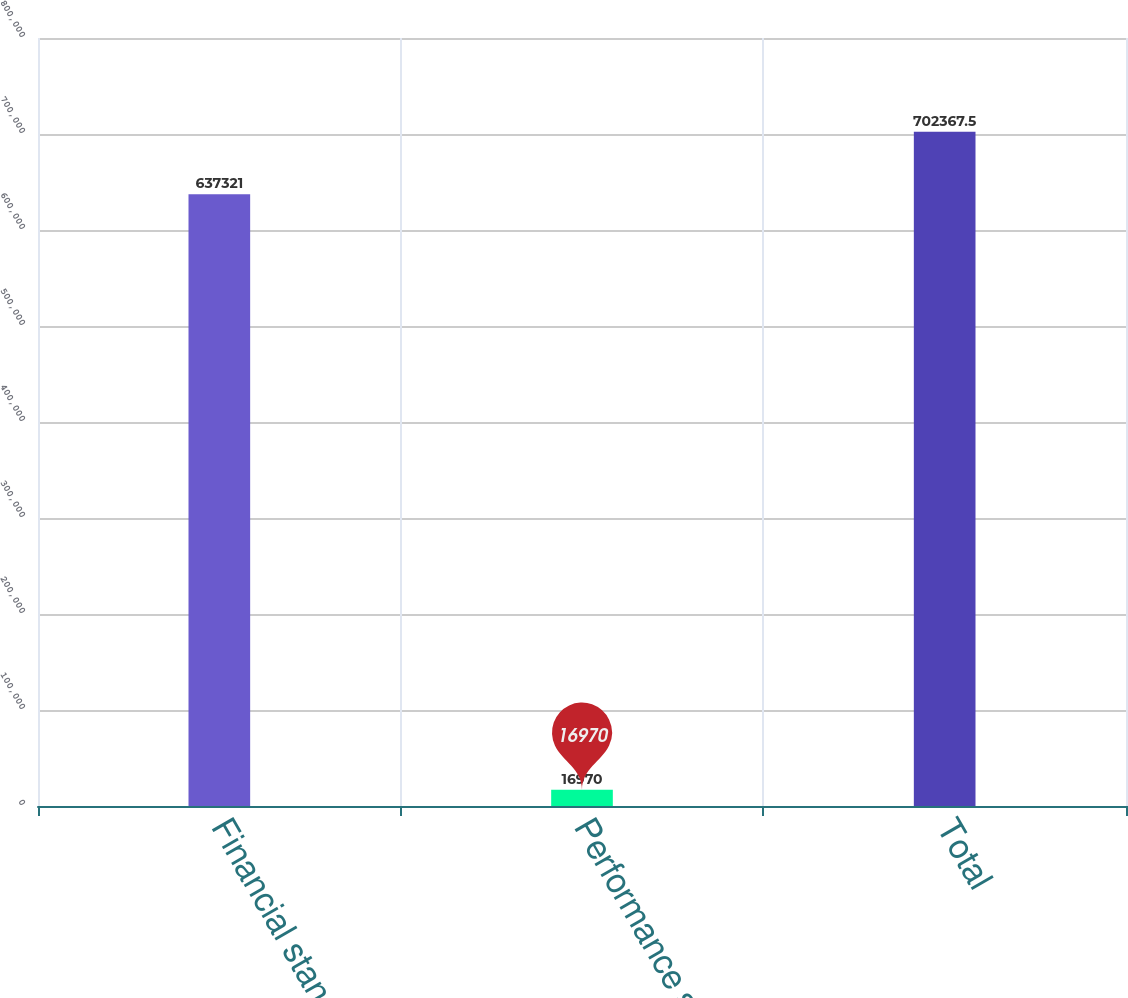Convert chart. <chart><loc_0><loc_0><loc_500><loc_500><bar_chart><fcel>Financial standby<fcel>Performance standby<fcel>Total<nl><fcel>637321<fcel>16970<fcel>702368<nl></chart> 